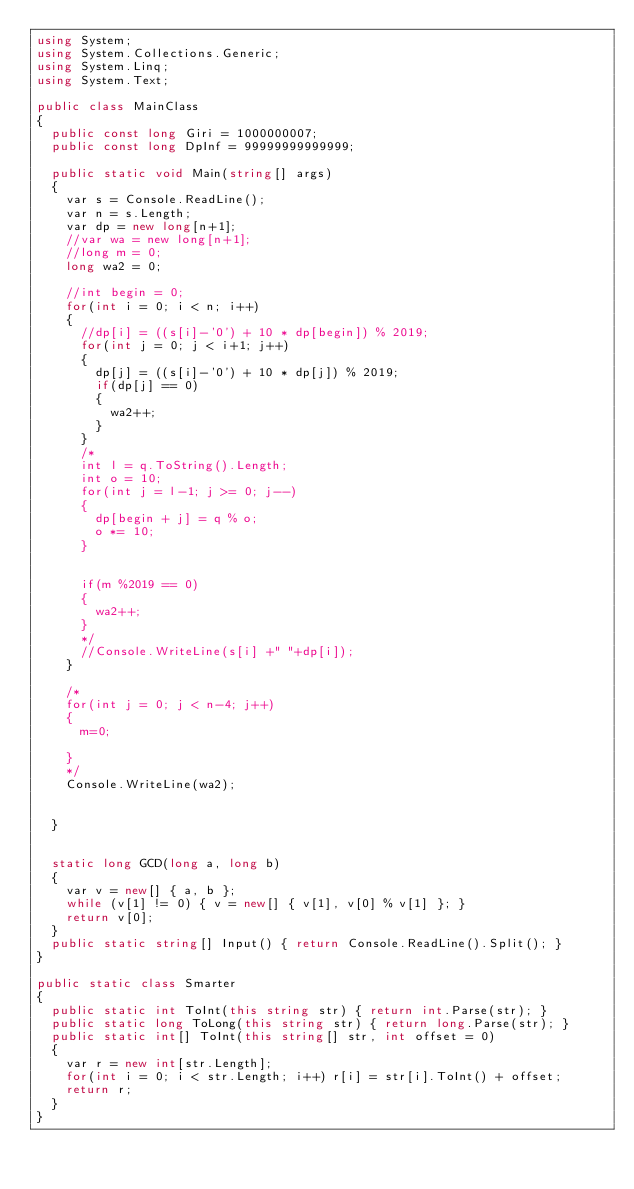<code> <loc_0><loc_0><loc_500><loc_500><_C#_>using System;
using System.Collections.Generic;
using System.Linq;
using System.Text;

public class MainClass
{
	public const long Giri = 1000000007;
	public const long DpInf = 99999999999999;
	
	public static void Main(string[] args)
	{
		var s = Console.ReadLine();
		var n = s.Length;
		var dp = new long[n+1];
		//var wa = new long[n+1];
		//long m = 0;
		long wa2 = 0;
		
		//int begin = 0;
		for(int i = 0; i < n; i++)
		{
			//dp[i] = ((s[i]-'0') + 10 * dp[begin]) % 2019;
			for(int j = 0; j < i+1; j++)
			{
				dp[j] = ((s[i]-'0') + 10 * dp[j]) % 2019;
				if(dp[j] == 0)
				{
					wa2++;
				}
			}
			/*
			int l = q.ToString().Length;
			int o = 10;
			for(int j = l-1; j >= 0; j--)
			{
				dp[begin + j] = q % o;
				o *= 10;
			}

			
			if(m %2019 == 0)
			{
				wa2++;
			}
			*/
			//Console.WriteLine(s[i] +" "+dp[i]);
		}
		
		/*
		for(int j = 0; j < n-4; j++)
		{
			m=0;

		}
		*/
		Console.WriteLine(wa2);


	}

	
	static long GCD(long a, long b)
	{
		var v = new[] { a, b };
		while (v[1] != 0) { v = new[] { v[1], v[0] % v[1] }; }
		return v[0];
	}
	public static string[] Input() { return Console.ReadLine().Split(); }
}

public static class Smarter
{
	public static int ToInt(this string str) { return int.Parse(str); }
	public static long ToLong(this string str) { return long.Parse(str); }
	public static int[] ToInt(this string[] str, int offset = 0)
	{
		var r = new int[str.Length];
		for(int i = 0; i < str.Length; i++) r[i] = str[i].ToInt() + offset;
		return r;
	}
}</code> 